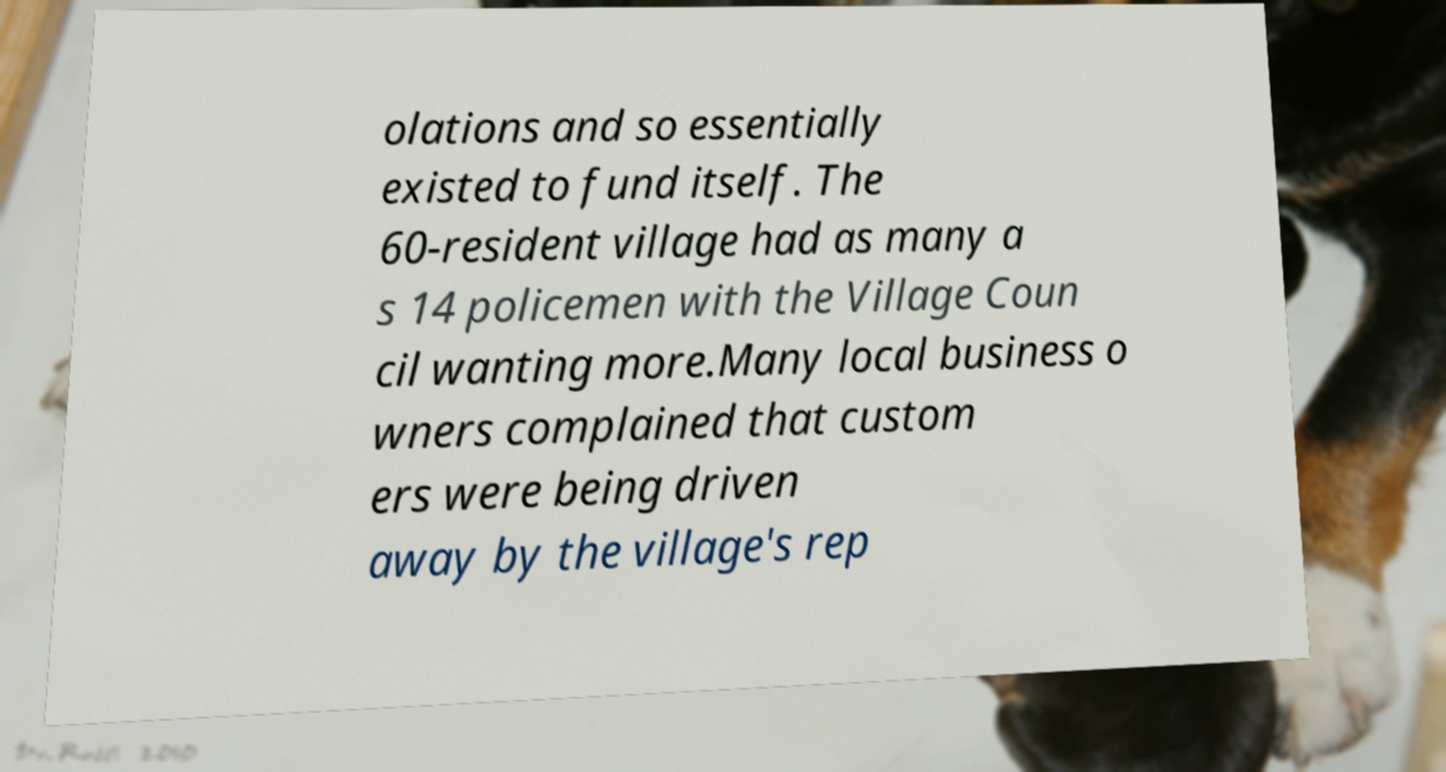Please identify and transcribe the text found in this image. olations and so essentially existed to fund itself. The 60-resident village had as many a s 14 policemen with the Village Coun cil wanting more.Many local business o wners complained that custom ers were being driven away by the village's rep 